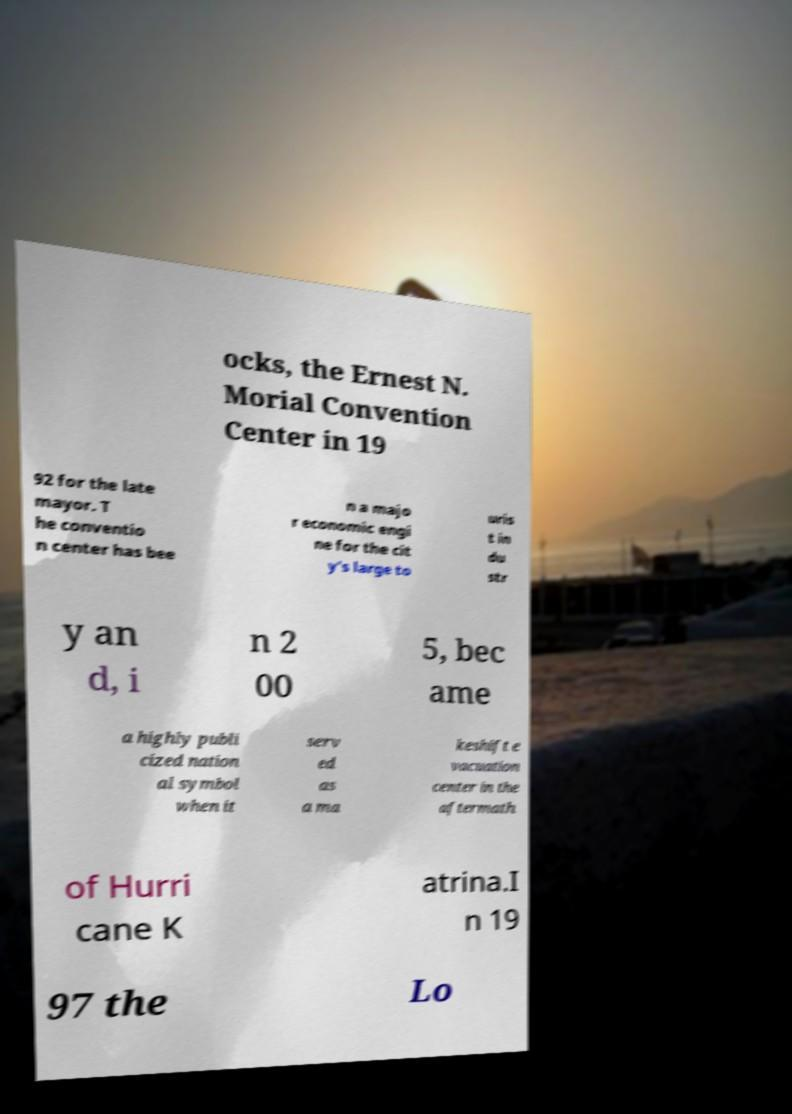What messages or text are displayed in this image? I need them in a readable, typed format. ocks, the Ernest N. Morial Convention Center in 19 92 for the late mayor. T he conventio n center has bee n a majo r economic engi ne for the cit y's large to uris t in du str y an d, i n 2 00 5, bec ame a highly publi cized nation al symbol when it serv ed as a ma keshift e vacuation center in the aftermath of Hurri cane K atrina.I n 19 97 the Lo 